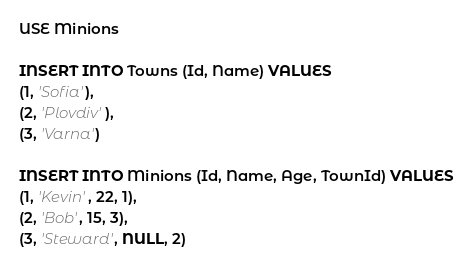<code> <loc_0><loc_0><loc_500><loc_500><_SQL_>USE Minions

INSERT INTO Towns (Id, Name) VALUES
(1, 'Sofia'),
(2, 'Plovdiv'),
(3, 'Varna')

INSERT INTO Minions (Id, Name, Age, TownId) VALUES 
(1, 'Kevin', 22, 1),
(2, 'Bob', 15, 3),
(3, 'Steward', NULL, 2)</code> 